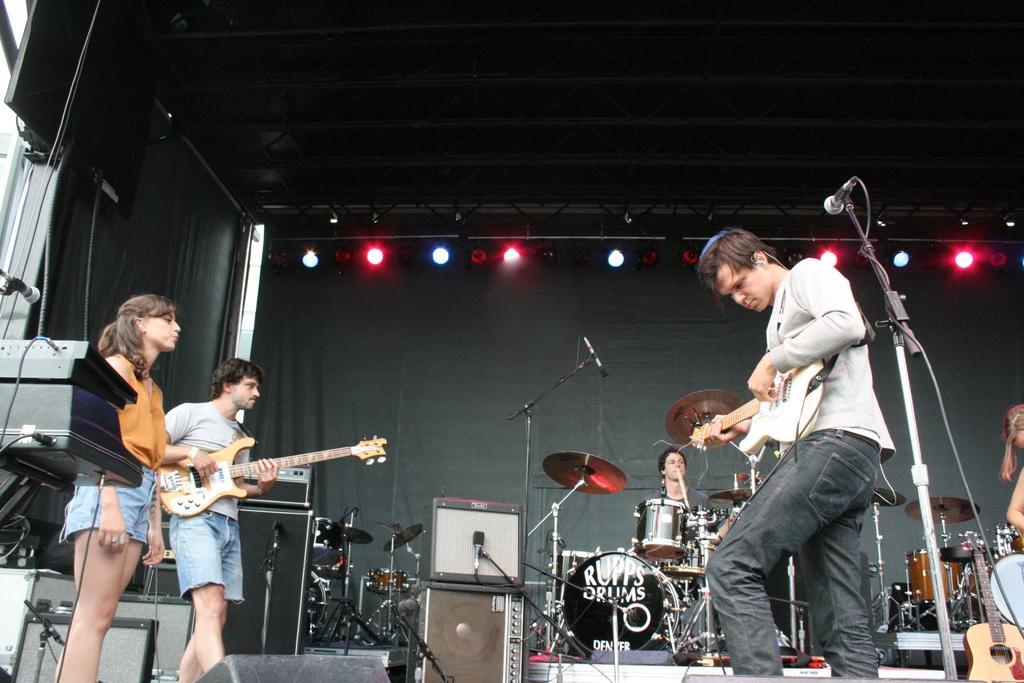Please provide a concise description of this image. This is a picture of a stage in a concert. On the right there is man standing and playing guitar. In the background a person is playing drums. On the right there is a guitar and drums. On the left a person standing and playing guitar, beside him a woman is standing. In the background there is a black curtain and focus lights. There are many microphones. 